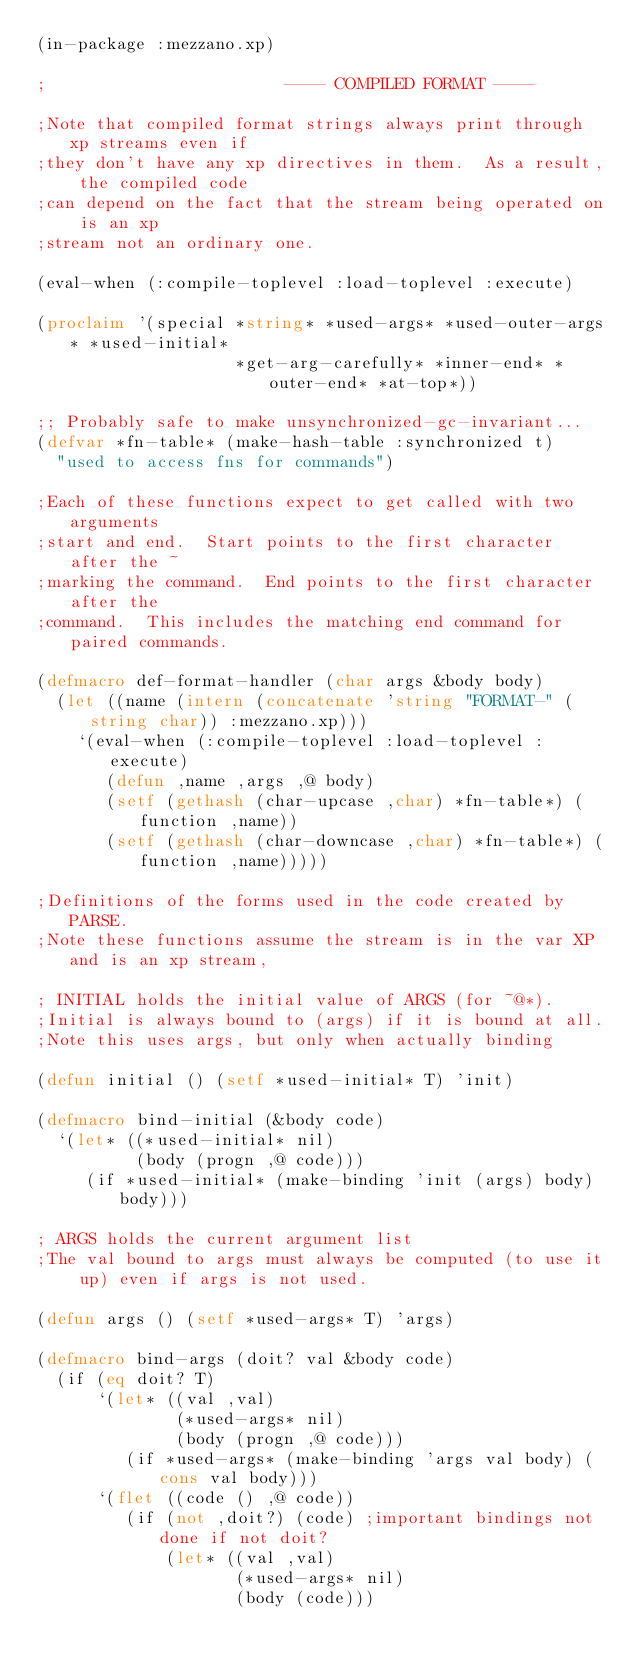<code> <loc_0><loc_0><loc_500><loc_500><_Lisp_>(in-package :mezzano.xp)

;                        ---- COMPILED FORMAT ----

;Note that compiled format strings always print through xp streams even if
;they don't have any xp directives in them.  As a result, the compiled code
;can depend on the fact that the stream being operated on is an xp
;stream not an ordinary one.

(eval-when (:compile-toplevel :load-toplevel :execute)

(proclaim '(special *string* *used-args* *used-outer-args* *used-initial*
                    *get-arg-carefully* *inner-end* *outer-end* *at-top*))

;; Probably safe to make unsynchronized-gc-invariant...
(defvar *fn-table* (make-hash-table :synchronized t)
  "used to access fns for commands")

;Each of these functions expect to get called with two arguments
;start and end.  Start points to the first character after the ~
;marking the command.  End points to the first character after the
;command.  This includes the matching end command for paired commands.

(defmacro def-format-handler (char args &body body)
  (let ((name (intern (concatenate 'string "FORMAT-" (string char)) :mezzano.xp)))
    `(eval-when (:compile-toplevel :load-toplevel :execute)
       (defun ,name ,args ,@ body)
       (setf (gethash (char-upcase ,char) *fn-table*) (function ,name))
       (setf (gethash (char-downcase ,char) *fn-table*) (function ,name)))))

;Definitions of the forms used in the code created by PARSE.
;Note these functions assume the stream is in the var XP and is an xp stream,

; INITIAL holds the initial value of ARGS (for ~@*).
;Initial is always bound to (args) if it is bound at all.
;Note this uses args, but only when actually binding

(defun initial () (setf *used-initial* T) 'init)

(defmacro bind-initial (&body code)
  `(let* ((*used-initial* nil)
          (body (progn ,@ code)))
     (if *used-initial* (make-binding 'init (args) body) body)))

; ARGS holds the current argument list
;The val bound to args must always be computed (to use it up) even if args is not used.

(defun args () (setf *used-args* T) 'args)

(defmacro bind-args (doit? val &body code)
  (if (eq doit? T)
      `(let* ((val ,val)
              (*used-args* nil)
              (body (progn ,@ code)))
         (if *used-args* (make-binding 'args val body) (cons val body)))
      `(flet ((code () ,@ code))
         (if (not ,doit?) (code) ;important bindings not done if not doit?
             (let* ((val ,val)
                    (*used-args* nil)
                    (body (code)))</code> 